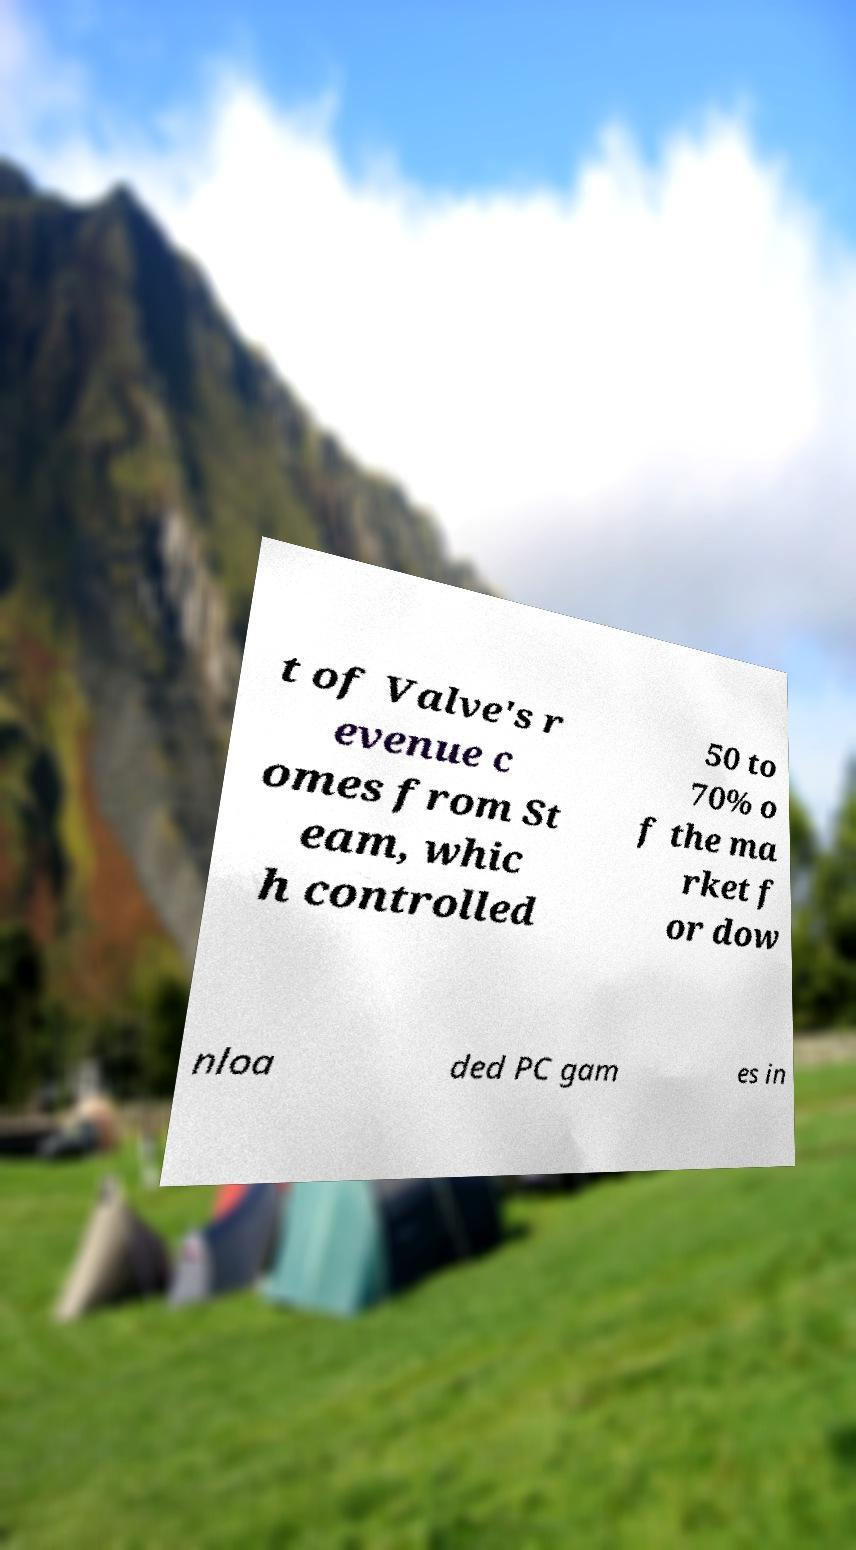There's text embedded in this image that I need extracted. Can you transcribe it verbatim? t of Valve's r evenue c omes from St eam, whic h controlled 50 to 70% o f the ma rket f or dow nloa ded PC gam es in 